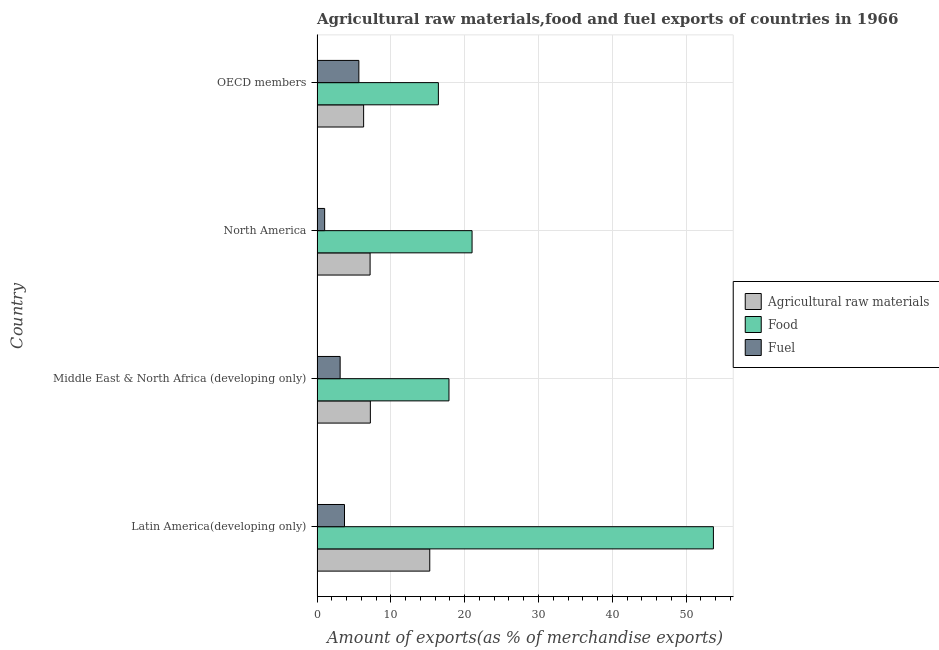How many groups of bars are there?
Make the answer very short. 4. How many bars are there on the 1st tick from the top?
Give a very brief answer. 3. What is the label of the 4th group of bars from the top?
Give a very brief answer. Latin America(developing only). In how many cases, is the number of bars for a given country not equal to the number of legend labels?
Make the answer very short. 0. What is the percentage of fuel exports in Latin America(developing only)?
Offer a very short reply. 3.72. Across all countries, what is the maximum percentage of food exports?
Give a very brief answer. 53.69. Across all countries, what is the minimum percentage of food exports?
Your response must be concise. 16.43. In which country was the percentage of fuel exports maximum?
Keep it short and to the point. OECD members. In which country was the percentage of food exports minimum?
Keep it short and to the point. OECD members. What is the total percentage of fuel exports in the graph?
Offer a terse response. 13.54. What is the difference between the percentage of fuel exports in Middle East & North Africa (developing only) and that in OECD members?
Make the answer very short. -2.54. What is the difference between the percentage of raw materials exports in OECD members and the percentage of food exports in North America?
Your answer should be compact. -14.69. What is the average percentage of food exports per country?
Offer a terse response. 27.25. What is the difference between the percentage of food exports and percentage of raw materials exports in OECD members?
Give a very brief answer. 10.13. In how many countries, is the percentage of food exports greater than 10 %?
Provide a succinct answer. 4. What is the ratio of the percentage of raw materials exports in Latin America(developing only) to that in North America?
Offer a terse response. 2.12. Is the percentage of raw materials exports in Middle East & North Africa (developing only) less than that in North America?
Keep it short and to the point. No. What is the difference between the highest and the second highest percentage of fuel exports?
Ensure brevity in your answer.  1.95. What is the difference between the highest and the lowest percentage of food exports?
Ensure brevity in your answer.  37.26. In how many countries, is the percentage of fuel exports greater than the average percentage of fuel exports taken over all countries?
Make the answer very short. 2. Is the sum of the percentage of raw materials exports in Middle East & North Africa (developing only) and OECD members greater than the maximum percentage of food exports across all countries?
Provide a short and direct response. No. What does the 2nd bar from the top in Middle East & North Africa (developing only) represents?
Offer a very short reply. Food. What does the 1st bar from the bottom in OECD members represents?
Provide a short and direct response. Agricultural raw materials. How many bars are there?
Your response must be concise. 12. How many countries are there in the graph?
Offer a very short reply. 4. What is the difference between two consecutive major ticks on the X-axis?
Your response must be concise. 10. Does the graph contain any zero values?
Your answer should be very brief. No. Does the graph contain grids?
Your answer should be compact. Yes. How many legend labels are there?
Offer a terse response. 3. How are the legend labels stacked?
Ensure brevity in your answer.  Vertical. What is the title of the graph?
Your response must be concise. Agricultural raw materials,food and fuel exports of countries in 1966. Does "Ages 65 and above" appear as one of the legend labels in the graph?
Your response must be concise. No. What is the label or title of the X-axis?
Your answer should be compact. Amount of exports(as % of merchandise exports). What is the label or title of the Y-axis?
Provide a short and direct response. Country. What is the Amount of exports(as % of merchandise exports) of Agricultural raw materials in Latin America(developing only)?
Your response must be concise. 15.27. What is the Amount of exports(as % of merchandise exports) of Food in Latin America(developing only)?
Make the answer very short. 53.69. What is the Amount of exports(as % of merchandise exports) of Fuel in Latin America(developing only)?
Your response must be concise. 3.72. What is the Amount of exports(as % of merchandise exports) of Agricultural raw materials in Middle East & North Africa (developing only)?
Your answer should be compact. 7.22. What is the Amount of exports(as % of merchandise exports) of Food in Middle East & North Africa (developing only)?
Offer a very short reply. 17.87. What is the Amount of exports(as % of merchandise exports) in Fuel in Middle East & North Africa (developing only)?
Make the answer very short. 3.13. What is the Amount of exports(as % of merchandise exports) of Agricultural raw materials in North America?
Provide a short and direct response. 7.19. What is the Amount of exports(as % of merchandise exports) in Food in North America?
Give a very brief answer. 21. What is the Amount of exports(as % of merchandise exports) in Fuel in North America?
Provide a short and direct response. 1.03. What is the Amount of exports(as % of merchandise exports) in Agricultural raw materials in OECD members?
Offer a very short reply. 6.31. What is the Amount of exports(as % of merchandise exports) in Food in OECD members?
Offer a terse response. 16.43. What is the Amount of exports(as % of merchandise exports) in Fuel in OECD members?
Your answer should be very brief. 5.66. Across all countries, what is the maximum Amount of exports(as % of merchandise exports) in Agricultural raw materials?
Give a very brief answer. 15.27. Across all countries, what is the maximum Amount of exports(as % of merchandise exports) in Food?
Ensure brevity in your answer.  53.69. Across all countries, what is the maximum Amount of exports(as % of merchandise exports) of Fuel?
Your answer should be very brief. 5.66. Across all countries, what is the minimum Amount of exports(as % of merchandise exports) in Agricultural raw materials?
Give a very brief answer. 6.31. Across all countries, what is the minimum Amount of exports(as % of merchandise exports) of Food?
Make the answer very short. 16.43. Across all countries, what is the minimum Amount of exports(as % of merchandise exports) in Fuel?
Your answer should be very brief. 1.03. What is the total Amount of exports(as % of merchandise exports) of Agricultural raw materials in the graph?
Keep it short and to the point. 35.99. What is the total Amount of exports(as % of merchandise exports) in Food in the graph?
Offer a very short reply. 108.99. What is the total Amount of exports(as % of merchandise exports) in Fuel in the graph?
Ensure brevity in your answer.  13.54. What is the difference between the Amount of exports(as % of merchandise exports) of Agricultural raw materials in Latin America(developing only) and that in Middle East & North Africa (developing only)?
Your answer should be compact. 8.05. What is the difference between the Amount of exports(as % of merchandise exports) in Food in Latin America(developing only) and that in Middle East & North Africa (developing only)?
Provide a succinct answer. 35.82. What is the difference between the Amount of exports(as % of merchandise exports) in Fuel in Latin America(developing only) and that in Middle East & North Africa (developing only)?
Provide a short and direct response. 0.59. What is the difference between the Amount of exports(as % of merchandise exports) of Agricultural raw materials in Latin America(developing only) and that in North America?
Offer a terse response. 8.08. What is the difference between the Amount of exports(as % of merchandise exports) in Food in Latin America(developing only) and that in North America?
Offer a terse response. 32.69. What is the difference between the Amount of exports(as % of merchandise exports) of Fuel in Latin America(developing only) and that in North America?
Give a very brief answer. 2.69. What is the difference between the Amount of exports(as % of merchandise exports) of Agricultural raw materials in Latin America(developing only) and that in OECD members?
Make the answer very short. 8.96. What is the difference between the Amount of exports(as % of merchandise exports) of Food in Latin America(developing only) and that in OECD members?
Offer a very short reply. 37.26. What is the difference between the Amount of exports(as % of merchandise exports) of Fuel in Latin America(developing only) and that in OECD members?
Offer a terse response. -1.95. What is the difference between the Amount of exports(as % of merchandise exports) in Agricultural raw materials in Middle East & North Africa (developing only) and that in North America?
Your answer should be compact. 0.04. What is the difference between the Amount of exports(as % of merchandise exports) of Food in Middle East & North Africa (developing only) and that in North America?
Provide a short and direct response. -3.13. What is the difference between the Amount of exports(as % of merchandise exports) of Fuel in Middle East & North Africa (developing only) and that in North America?
Offer a terse response. 2.1. What is the difference between the Amount of exports(as % of merchandise exports) in Agricultural raw materials in Middle East & North Africa (developing only) and that in OECD members?
Your response must be concise. 0.91. What is the difference between the Amount of exports(as % of merchandise exports) in Food in Middle East & North Africa (developing only) and that in OECD members?
Make the answer very short. 1.43. What is the difference between the Amount of exports(as % of merchandise exports) of Fuel in Middle East & North Africa (developing only) and that in OECD members?
Provide a succinct answer. -2.54. What is the difference between the Amount of exports(as % of merchandise exports) in Agricultural raw materials in North America and that in OECD members?
Provide a succinct answer. 0.88. What is the difference between the Amount of exports(as % of merchandise exports) in Food in North America and that in OECD members?
Your response must be concise. 4.56. What is the difference between the Amount of exports(as % of merchandise exports) of Fuel in North America and that in OECD members?
Keep it short and to the point. -4.63. What is the difference between the Amount of exports(as % of merchandise exports) of Agricultural raw materials in Latin America(developing only) and the Amount of exports(as % of merchandise exports) of Food in Middle East & North Africa (developing only)?
Provide a succinct answer. -2.6. What is the difference between the Amount of exports(as % of merchandise exports) of Agricultural raw materials in Latin America(developing only) and the Amount of exports(as % of merchandise exports) of Fuel in Middle East & North Africa (developing only)?
Offer a very short reply. 12.14. What is the difference between the Amount of exports(as % of merchandise exports) in Food in Latin America(developing only) and the Amount of exports(as % of merchandise exports) in Fuel in Middle East & North Africa (developing only)?
Ensure brevity in your answer.  50.56. What is the difference between the Amount of exports(as % of merchandise exports) of Agricultural raw materials in Latin America(developing only) and the Amount of exports(as % of merchandise exports) of Food in North America?
Offer a very short reply. -5.73. What is the difference between the Amount of exports(as % of merchandise exports) of Agricultural raw materials in Latin America(developing only) and the Amount of exports(as % of merchandise exports) of Fuel in North America?
Make the answer very short. 14.24. What is the difference between the Amount of exports(as % of merchandise exports) in Food in Latin America(developing only) and the Amount of exports(as % of merchandise exports) in Fuel in North America?
Keep it short and to the point. 52.66. What is the difference between the Amount of exports(as % of merchandise exports) in Agricultural raw materials in Latin America(developing only) and the Amount of exports(as % of merchandise exports) in Food in OECD members?
Ensure brevity in your answer.  -1.17. What is the difference between the Amount of exports(as % of merchandise exports) of Agricultural raw materials in Latin America(developing only) and the Amount of exports(as % of merchandise exports) of Fuel in OECD members?
Ensure brevity in your answer.  9.61. What is the difference between the Amount of exports(as % of merchandise exports) in Food in Latin America(developing only) and the Amount of exports(as % of merchandise exports) in Fuel in OECD members?
Offer a terse response. 48.03. What is the difference between the Amount of exports(as % of merchandise exports) of Agricultural raw materials in Middle East & North Africa (developing only) and the Amount of exports(as % of merchandise exports) of Food in North America?
Make the answer very short. -13.78. What is the difference between the Amount of exports(as % of merchandise exports) of Agricultural raw materials in Middle East & North Africa (developing only) and the Amount of exports(as % of merchandise exports) of Fuel in North America?
Offer a terse response. 6.19. What is the difference between the Amount of exports(as % of merchandise exports) in Food in Middle East & North Africa (developing only) and the Amount of exports(as % of merchandise exports) in Fuel in North America?
Offer a terse response. 16.84. What is the difference between the Amount of exports(as % of merchandise exports) in Agricultural raw materials in Middle East & North Africa (developing only) and the Amount of exports(as % of merchandise exports) in Food in OECD members?
Your answer should be compact. -9.21. What is the difference between the Amount of exports(as % of merchandise exports) of Agricultural raw materials in Middle East & North Africa (developing only) and the Amount of exports(as % of merchandise exports) of Fuel in OECD members?
Make the answer very short. 1.56. What is the difference between the Amount of exports(as % of merchandise exports) in Food in Middle East & North Africa (developing only) and the Amount of exports(as % of merchandise exports) in Fuel in OECD members?
Your response must be concise. 12.2. What is the difference between the Amount of exports(as % of merchandise exports) of Agricultural raw materials in North America and the Amount of exports(as % of merchandise exports) of Food in OECD members?
Your answer should be very brief. -9.25. What is the difference between the Amount of exports(as % of merchandise exports) in Agricultural raw materials in North America and the Amount of exports(as % of merchandise exports) in Fuel in OECD members?
Your answer should be very brief. 1.52. What is the difference between the Amount of exports(as % of merchandise exports) of Food in North America and the Amount of exports(as % of merchandise exports) of Fuel in OECD members?
Your answer should be very brief. 15.33. What is the average Amount of exports(as % of merchandise exports) of Agricultural raw materials per country?
Ensure brevity in your answer.  9. What is the average Amount of exports(as % of merchandise exports) in Food per country?
Offer a terse response. 27.25. What is the average Amount of exports(as % of merchandise exports) in Fuel per country?
Offer a very short reply. 3.38. What is the difference between the Amount of exports(as % of merchandise exports) of Agricultural raw materials and Amount of exports(as % of merchandise exports) of Food in Latin America(developing only)?
Give a very brief answer. -38.42. What is the difference between the Amount of exports(as % of merchandise exports) of Agricultural raw materials and Amount of exports(as % of merchandise exports) of Fuel in Latin America(developing only)?
Your answer should be very brief. 11.55. What is the difference between the Amount of exports(as % of merchandise exports) in Food and Amount of exports(as % of merchandise exports) in Fuel in Latin America(developing only)?
Your answer should be very brief. 49.97. What is the difference between the Amount of exports(as % of merchandise exports) of Agricultural raw materials and Amount of exports(as % of merchandise exports) of Food in Middle East & North Africa (developing only)?
Offer a terse response. -10.65. What is the difference between the Amount of exports(as % of merchandise exports) of Agricultural raw materials and Amount of exports(as % of merchandise exports) of Fuel in Middle East & North Africa (developing only)?
Make the answer very short. 4.09. What is the difference between the Amount of exports(as % of merchandise exports) of Food and Amount of exports(as % of merchandise exports) of Fuel in Middle East & North Africa (developing only)?
Make the answer very short. 14.74. What is the difference between the Amount of exports(as % of merchandise exports) of Agricultural raw materials and Amount of exports(as % of merchandise exports) of Food in North America?
Ensure brevity in your answer.  -13.81. What is the difference between the Amount of exports(as % of merchandise exports) in Agricultural raw materials and Amount of exports(as % of merchandise exports) in Fuel in North America?
Keep it short and to the point. 6.16. What is the difference between the Amount of exports(as % of merchandise exports) in Food and Amount of exports(as % of merchandise exports) in Fuel in North America?
Give a very brief answer. 19.97. What is the difference between the Amount of exports(as % of merchandise exports) of Agricultural raw materials and Amount of exports(as % of merchandise exports) of Food in OECD members?
Make the answer very short. -10.13. What is the difference between the Amount of exports(as % of merchandise exports) of Agricultural raw materials and Amount of exports(as % of merchandise exports) of Fuel in OECD members?
Provide a succinct answer. 0.65. What is the difference between the Amount of exports(as % of merchandise exports) in Food and Amount of exports(as % of merchandise exports) in Fuel in OECD members?
Provide a succinct answer. 10.77. What is the ratio of the Amount of exports(as % of merchandise exports) of Agricultural raw materials in Latin America(developing only) to that in Middle East & North Africa (developing only)?
Offer a terse response. 2.11. What is the ratio of the Amount of exports(as % of merchandise exports) in Food in Latin America(developing only) to that in Middle East & North Africa (developing only)?
Keep it short and to the point. 3. What is the ratio of the Amount of exports(as % of merchandise exports) of Fuel in Latin America(developing only) to that in Middle East & North Africa (developing only)?
Ensure brevity in your answer.  1.19. What is the ratio of the Amount of exports(as % of merchandise exports) of Agricultural raw materials in Latin America(developing only) to that in North America?
Your response must be concise. 2.12. What is the ratio of the Amount of exports(as % of merchandise exports) in Food in Latin America(developing only) to that in North America?
Provide a succinct answer. 2.56. What is the ratio of the Amount of exports(as % of merchandise exports) of Fuel in Latin America(developing only) to that in North America?
Provide a short and direct response. 3.61. What is the ratio of the Amount of exports(as % of merchandise exports) of Agricultural raw materials in Latin America(developing only) to that in OECD members?
Your response must be concise. 2.42. What is the ratio of the Amount of exports(as % of merchandise exports) of Food in Latin America(developing only) to that in OECD members?
Ensure brevity in your answer.  3.27. What is the ratio of the Amount of exports(as % of merchandise exports) in Fuel in Latin America(developing only) to that in OECD members?
Give a very brief answer. 0.66. What is the ratio of the Amount of exports(as % of merchandise exports) of Agricultural raw materials in Middle East & North Africa (developing only) to that in North America?
Your response must be concise. 1. What is the ratio of the Amount of exports(as % of merchandise exports) of Food in Middle East & North Africa (developing only) to that in North America?
Provide a succinct answer. 0.85. What is the ratio of the Amount of exports(as % of merchandise exports) in Fuel in Middle East & North Africa (developing only) to that in North America?
Your response must be concise. 3.04. What is the ratio of the Amount of exports(as % of merchandise exports) in Agricultural raw materials in Middle East & North Africa (developing only) to that in OECD members?
Offer a terse response. 1.14. What is the ratio of the Amount of exports(as % of merchandise exports) of Food in Middle East & North Africa (developing only) to that in OECD members?
Offer a terse response. 1.09. What is the ratio of the Amount of exports(as % of merchandise exports) in Fuel in Middle East & North Africa (developing only) to that in OECD members?
Your response must be concise. 0.55. What is the ratio of the Amount of exports(as % of merchandise exports) in Agricultural raw materials in North America to that in OECD members?
Offer a terse response. 1.14. What is the ratio of the Amount of exports(as % of merchandise exports) in Food in North America to that in OECD members?
Your answer should be compact. 1.28. What is the ratio of the Amount of exports(as % of merchandise exports) in Fuel in North America to that in OECD members?
Offer a terse response. 0.18. What is the difference between the highest and the second highest Amount of exports(as % of merchandise exports) of Agricultural raw materials?
Your answer should be compact. 8.05. What is the difference between the highest and the second highest Amount of exports(as % of merchandise exports) in Food?
Offer a very short reply. 32.69. What is the difference between the highest and the second highest Amount of exports(as % of merchandise exports) in Fuel?
Your response must be concise. 1.95. What is the difference between the highest and the lowest Amount of exports(as % of merchandise exports) of Agricultural raw materials?
Your response must be concise. 8.96. What is the difference between the highest and the lowest Amount of exports(as % of merchandise exports) in Food?
Offer a terse response. 37.26. What is the difference between the highest and the lowest Amount of exports(as % of merchandise exports) of Fuel?
Keep it short and to the point. 4.63. 